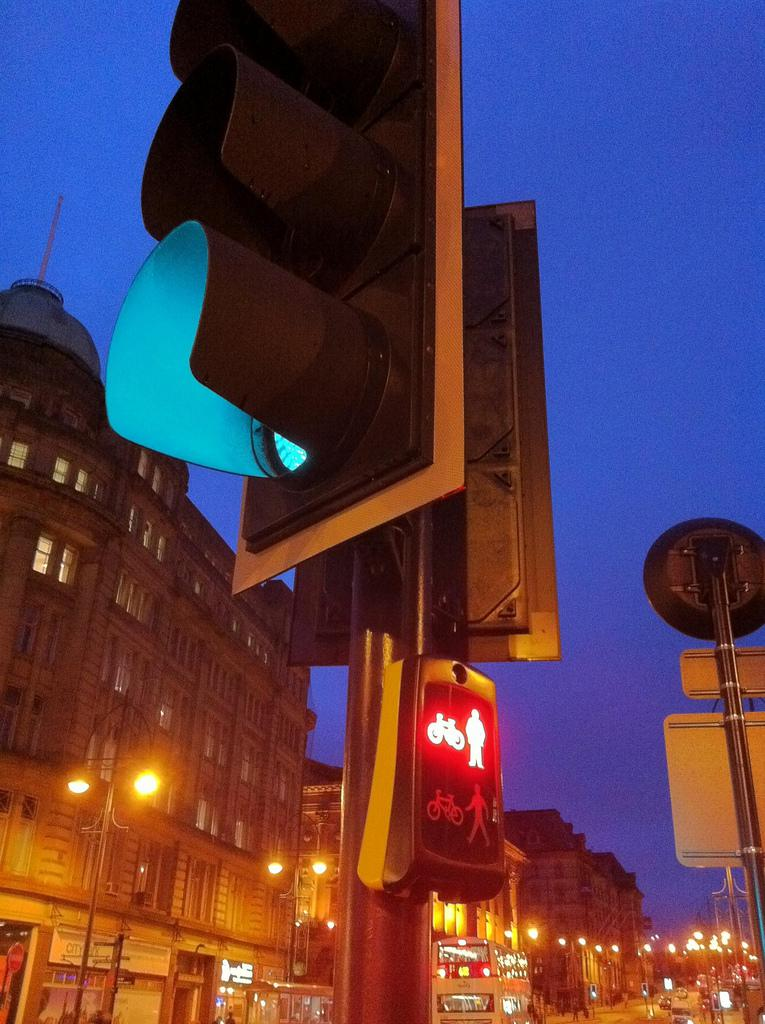Question: what is lit up?
Choices:
A. The walk sign.
B. The don't walk sign.
C. The slow down sign.
D. The roadwork sign.
Answer with the letter. Answer: B Question: what color is the traffic light?
Choices:
A. Red.
B. Green.
C. Yellow.
D. Orange.
Answer with the letter. Answer: B Question: how many decks does the bus have?
Choices:
A. 1.
B. 3.
C. 2.
D. 5.
Answer with the letter. Answer: C Question: when was this picture taken?
Choices:
A. At dusk.
B. In the evening.
C. At dawn.
D. In the afternoon.
Answer with the letter. Answer: B Question: why is there a street light?
Choices:
A. The prevent accidents.
B. To control traffic.
C. To organize traffic flow.
D. To provide visability.
Answer with the letter. Answer: B Question: what color is the light?
Choices:
A. Yellow.
B. Green.
C. Blue.
D. Red.
Answer with the letter. Answer: B Question: who uses the street light?
Choices:
A. Bicyclists.
B. Pedestrians.
C. Drag racers.
D. Drivers.
Answer with the letter. Answer: D Question: what does the red light mean?
Choices:
A. Stop.
B. Don't go.
C. No crossing.
D. Wait.
Answer with the letter. Answer: C Question: what is parked and waiting for passengers?
Choices:
A. The yellow taxi cab.
B. A double decker bus.
C. A black minivan.
D. A shuttle bus.
Answer with the letter. Answer: B Question: where is the double decker bus?
Choices:
A. Stopped at the red light.
B. In front of the bus stop.
C. In the distance.
D. Parked in the bus depot.
Answer with the letter. Answer: C Question: what is adorning the bare streets?
Choices:
A. Bus stop signs.
B. A lamp post.
C. A stop sign.
D. Street lights.
Answer with the letter. Answer: D Question: what color street lights are running along the streets?
Choices:
A. Blue.
B. White.
C. Yellowish.
D. Red.
Answer with the letter. Answer: C Question: what is on buildings?
Choices:
A. Windows.
B. Lights.
C. Graffiti.
D. Street signs.
Answer with the letter. Answer: B Question: what is blue?
Choices:
A. Truck.
B. Sky.
C. Children's uniforms.
D. Flowers.
Answer with the letter. Answer: B 